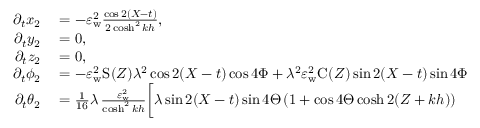Convert formula to latex. <formula><loc_0><loc_0><loc_500><loc_500>\begin{array} { r l } { \partial _ { t } x _ { 2 } } & = - \varepsilon _ { w } ^ { 2 } \frac { \cos 2 ( X - t ) } { 2 \cosh ^ { 2 } k h } , } \\ { \partial _ { t } y _ { 2 } } & = 0 , } \\ { \partial _ { t } z _ { 2 } } & = 0 , } \\ { \partial _ { t } { \phi _ { 2 } } } & = - \varepsilon _ { w } ^ { 2 } S ( Z ) \lambda ^ { 2 } \cos 2 ( X - t ) \cos { 4 \Phi } + \lambda ^ { 2 } \varepsilon _ { w } ^ { 2 } C ( Z ) \sin 2 ( X - t ) \sin { 4 \Phi } } \\ { \partial _ { t } { \theta _ { 2 } } } & = \frac { 1 } { 1 6 } \lambda \, \frac { \varepsilon _ { w } ^ { 2 } } { \cosh ^ { 2 } k h } \Big [ \lambda \sin 2 ( X - t ) \sin { 4 \Theta } \, ( 1 + \cos { 4 \Theta } \cosh 2 ( Z + k h ) ) } \end{array}</formula> 